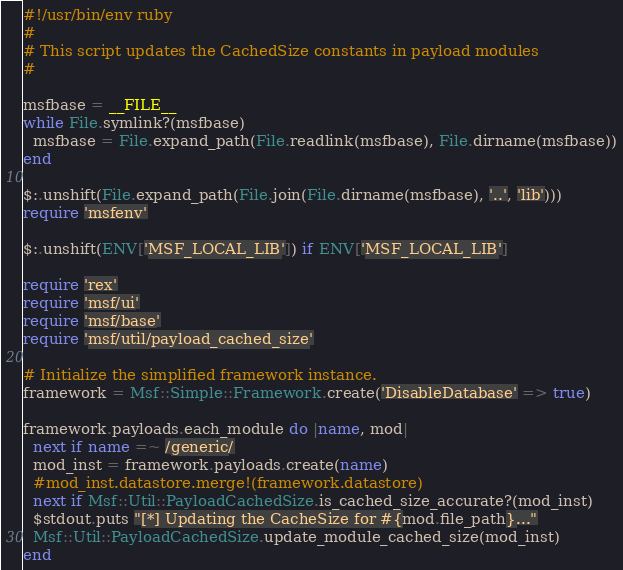Convert code to text. <code><loc_0><loc_0><loc_500><loc_500><_Ruby_>#!/usr/bin/env ruby
#
# This script updates the CachedSize constants in payload modules
#

msfbase = __FILE__
while File.symlink?(msfbase)
  msfbase = File.expand_path(File.readlink(msfbase), File.dirname(msfbase))
end

$:.unshift(File.expand_path(File.join(File.dirname(msfbase), '..', 'lib')))
require 'msfenv'

$:.unshift(ENV['MSF_LOCAL_LIB']) if ENV['MSF_LOCAL_LIB']

require 'rex'
require 'msf/ui'
require 'msf/base'
require 'msf/util/payload_cached_size'

# Initialize the simplified framework instance.
framework = Msf::Simple::Framework.create('DisableDatabase' => true)

framework.payloads.each_module do |name, mod|
  next if name =~ /generic/
  mod_inst = framework.payloads.create(name)
  #mod_inst.datastore.merge!(framework.datastore)
  next if Msf::Util::PayloadCachedSize.is_cached_size_accurate?(mod_inst)
  $stdout.puts "[*] Updating the CacheSize for #{mod.file_path}..."
  Msf::Util::PayloadCachedSize.update_module_cached_size(mod_inst)
end

</code> 